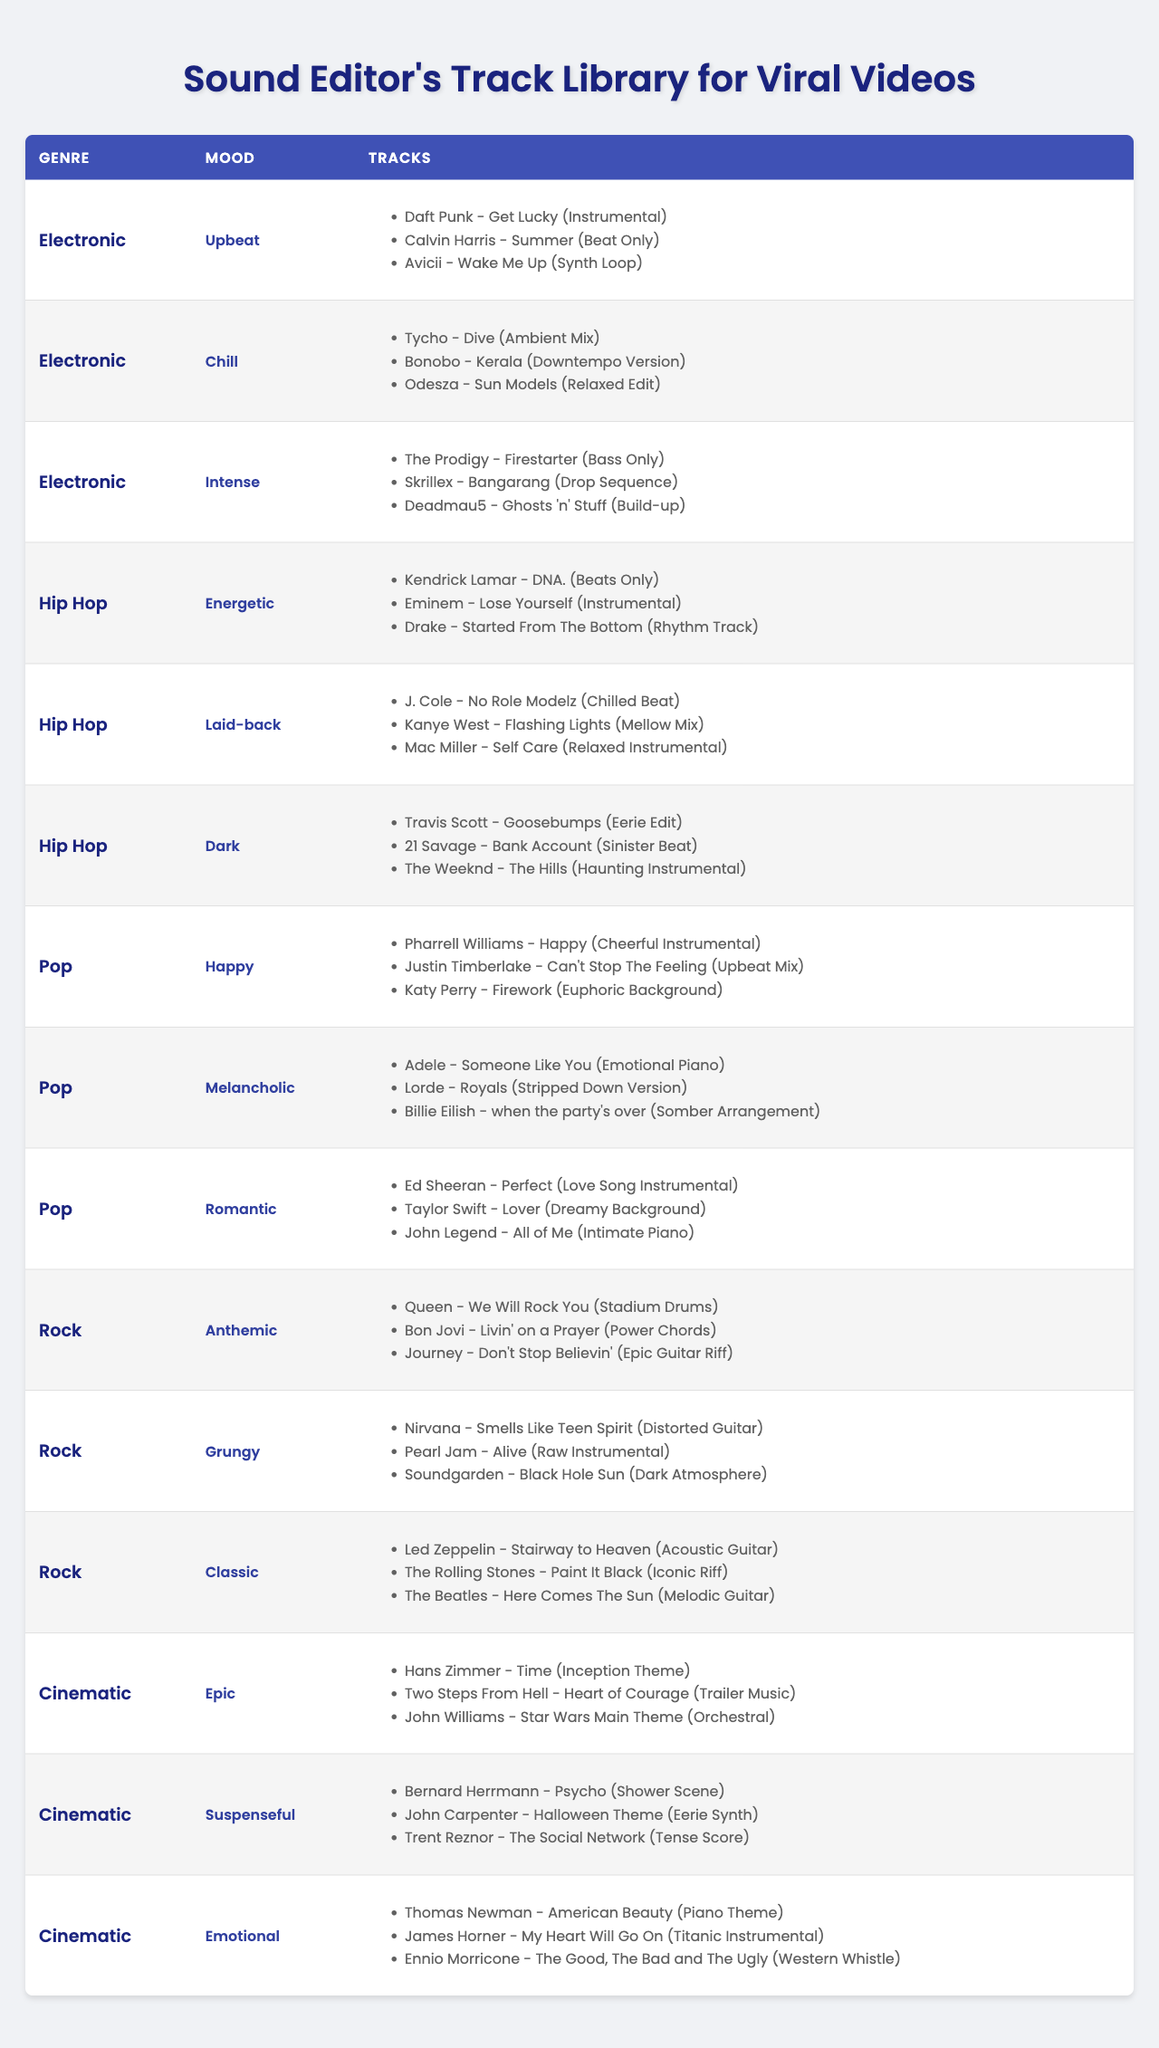What's the total number of tracks listed under the genre Pop? There are three moods under the genre Pop: Happy, Melancholic, and Romantic, each with three tracks, so the total is 3 + 3 + 3 = 9.
Answer: 9 Which genre has the most tracks categorized under the mood Chill? Only the Electronic genre has tracks categorized under the mood Chill, and it has three tracks listed.
Answer: Electronic Is there any track listed under the genre Rock that has a Grungy mood? Yes, there are three tracks listed under the genre Rock with a Grungy mood.
Answer: Yes What is the difference in the number of tracks between the Pop genre and the Hip Hop genre? Pop has 9 tracks (3 for each of the 3 moods) while Hip Hop has 9 tracks as well (3 for each of the 3 moods), so the difference is 9 - 9 = 0.
Answer: 0 How many tracks are there in total across all genres and moods? Each genre has 3 moods, most with 3 tracks, totaling 4 genres x 3 moods x 3 tracks = 36.
Answer: 36 Which genre has fewer tracks, Electronic or Cinematic? Electronic has 9 tracks (3 for each of its 3 moods), while Cinematic also has 9 tracks, so they are equal.
Answer: Equal Are there more tracks with an Intense mood in the Electronic genre or more tracks with a Romantic mood in the Pop genre? Both the Electronic genre (3 tracks with Intense mood) and the Pop genre (3 tracks with Romantic mood) have the same number of tracks, so it's equal.
Answer: Equal List the three tracks listed under the mood Emotional in the Cinematic genre. The tracks are: Thomas Newman - American Beauty (Piano Theme), James Horner - My Heart Will Go On (Titanic Instrumental), and Ennio Morricone - The Good, The Bad and the Ugly (Western Whistle).
Answer: 3 tracks Which genre has a track that includes "We Will Rock You"? The track "We Will Rock You" is listed under the Rock genre.
Answer: Rock How many moods in the Hip Hop genre contain tracks categorized as Laid-back? The Hip Hop genre has only one mood that contains tracks categorized as Laid-back.
Answer: 1 